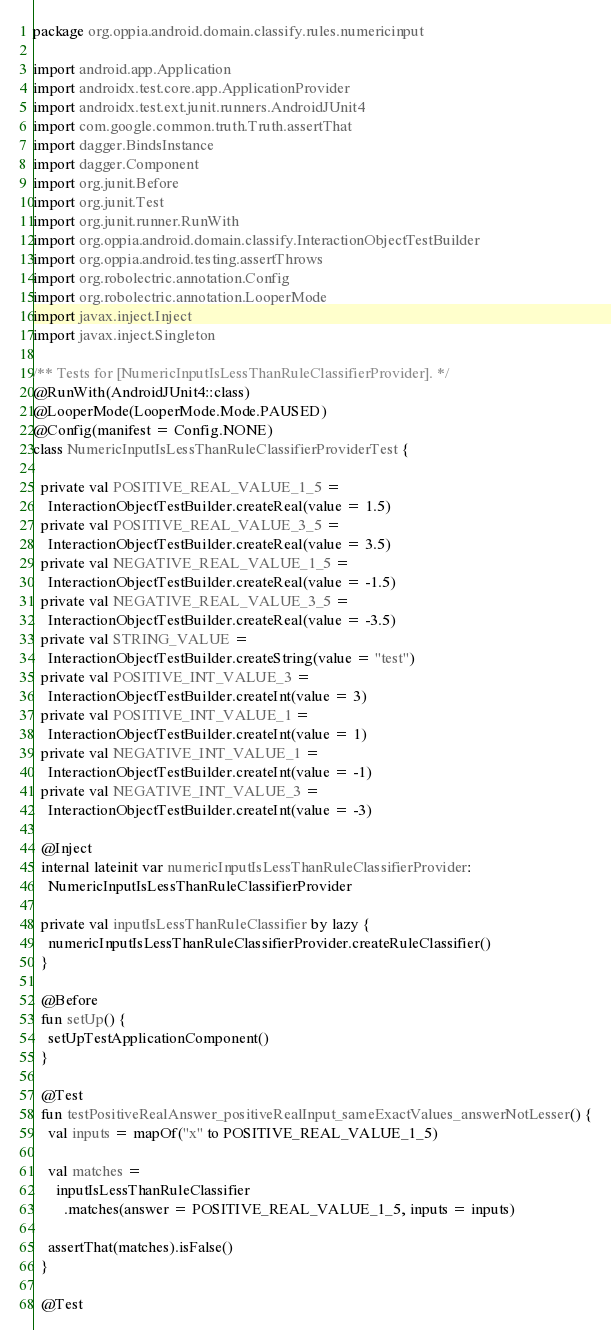Convert code to text. <code><loc_0><loc_0><loc_500><loc_500><_Kotlin_>package org.oppia.android.domain.classify.rules.numericinput

import android.app.Application
import androidx.test.core.app.ApplicationProvider
import androidx.test.ext.junit.runners.AndroidJUnit4
import com.google.common.truth.Truth.assertThat
import dagger.BindsInstance
import dagger.Component
import org.junit.Before
import org.junit.Test
import org.junit.runner.RunWith
import org.oppia.android.domain.classify.InteractionObjectTestBuilder
import org.oppia.android.testing.assertThrows
import org.robolectric.annotation.Config
import org.robolectric.annotation.LooperMode
import javax.inject.Inject
import javax.inject.Singleton

/** Tests for [NumericInputIsLessThanRuleClassifierProvider]. */
@RunWith(AndroidJUnit4::class)
@LooperMode(LooperMode.Mode.PAUSED)
@Config(manifest = Config.NONE)
class NumericInputIsLessThanRuleClassifierProviderTest {

  private val POSITIVE_REAL_VALUE_1_5 =
    InteractionObjectTestBuilder.createReal(value = 1.5)
  private val POSITIVE_REAL_VALUE_3_5 =
    InteractionObjectTestBuilder.createReal(value = 3.5)
  private val NEGATIVE_REAL_VALUE_1_5 =
    InteractionObjectTestBuilder.createReal(value = -1.5)
  private val NEGATIVE_REAL_VALUE_3_5 =
    InteractionObjectTestBuilder.createReal(value = -3.5)
  private val STRING_VALUE =
    InteractionObjectTestBuilder.createString(value = "test")
  private val POSITIVE_INT_VALUE_3 =
    InteractionObjectTestBuilder.createInt(value = 3)
  private val POSITIVE_INT_VALUE_1 =
    InteractionObjectTestBuilder.createInt(value = 1)
  private val NEGATIVE_INT_VALUE_1 =
    InteractionObjectTestBuilder.createInt(value = -1)
  private val NEGATIVE_INT_VALUE_3 =
    InteractionObjectTestBuilder.createInt(value = -3)

  @Inject
  internal lateinit var numericInputIsLessThanRuleClassifierProvider:
    NumericInputIsLessThanRuleClassifierProvider

  private val inputIsLessThanRuleClassifier by lazy {
    numericInputIsLessThanRuleClassifierProvider.createRuleClassifier()
  }

  @Before
  fun setUp() {
    setUpTestApplicationComponent()
  }

  @Test
  fun testPositiveRealAnswer_positiveRealInput_sameExactValues_answerNotLesser() {
    val inputs = mapOf("x" to POSITIVE_REAL_VALUE_1_5)

    val matches =
      inputIsLessThanRuleClassifier
        .matches(answer = POSITIVE_REAL_VALUE_1_5, inputs = inputs)

    assertThat(matches).isFalse()
  }

  @Test</code> 